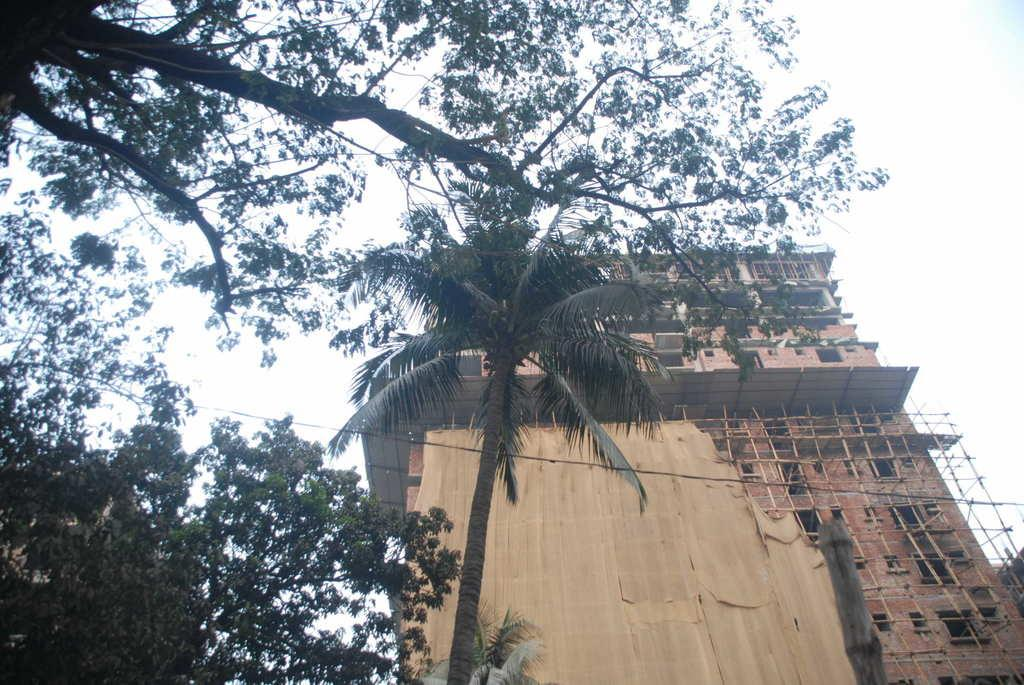What is located in the middle of the image? There are trees and a building in the middle of the image. What can be seen at the top of the image? The sky is visible at the top of the image. How many arms are visible in the image? There are no arms visible in the image. What type of boats can be seen in the image? There are no boats present in the image. 